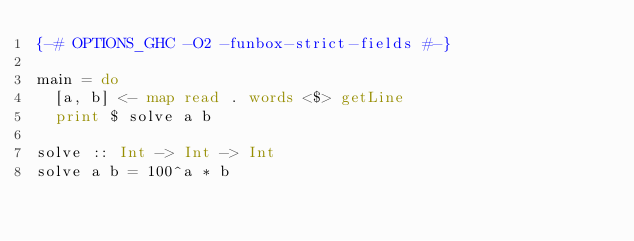<code> <loc_0><loc_0><loc_500><loc_500><_Haskell_>{-# OPTIONS_GHC -O2 -funbox-strict-fields #-}

main = do
  [a, b] <- map read . words <$> getLine
  print $ solve a b

solve :: Int -> Int -> Int
solve a b = 100^a * b
</code> 